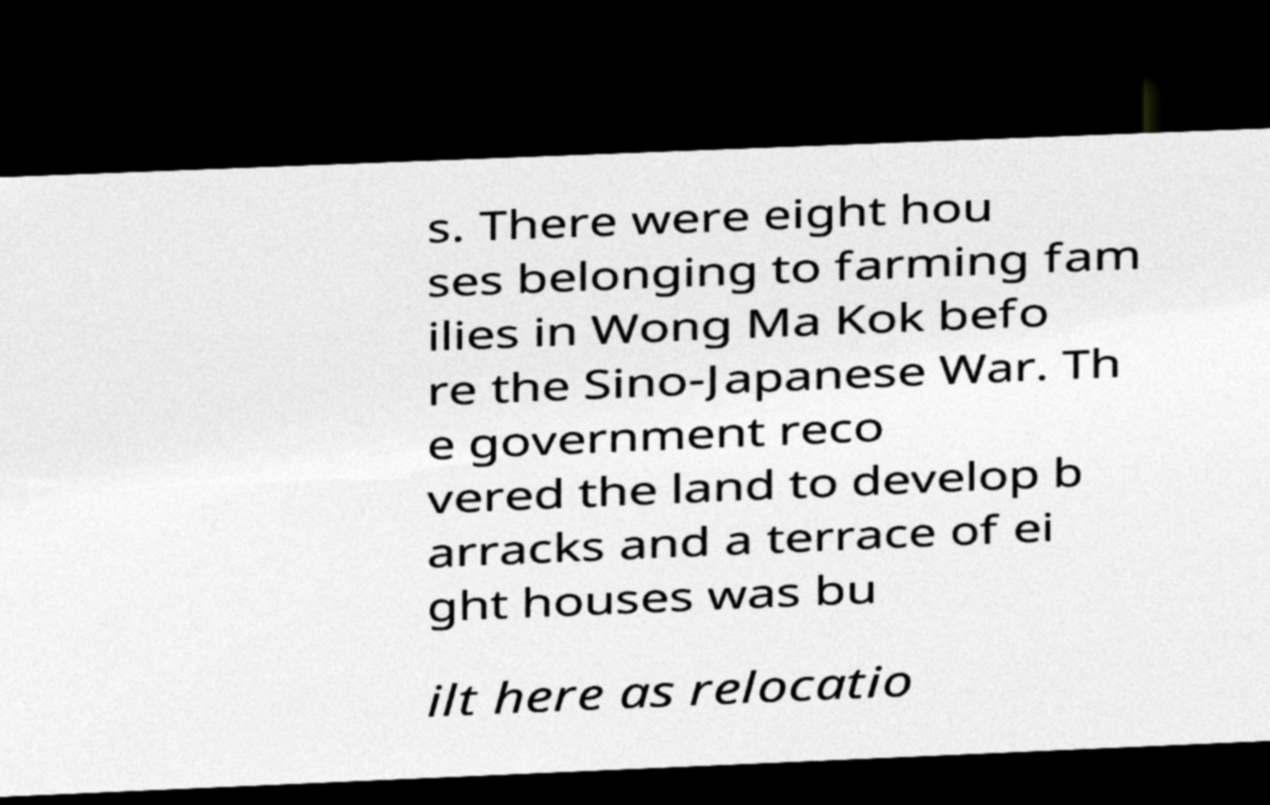What messages or text are displayed in this image? I need them in a readable, typed format. s. There were eight hou ses belonging to farming fam ilies in Wong Ma Kok befo re the Sino-Japanese War. Th e government reco vered the land to develop b arracks and a terrace of ei ght houses was bu ilt here as relocatio 